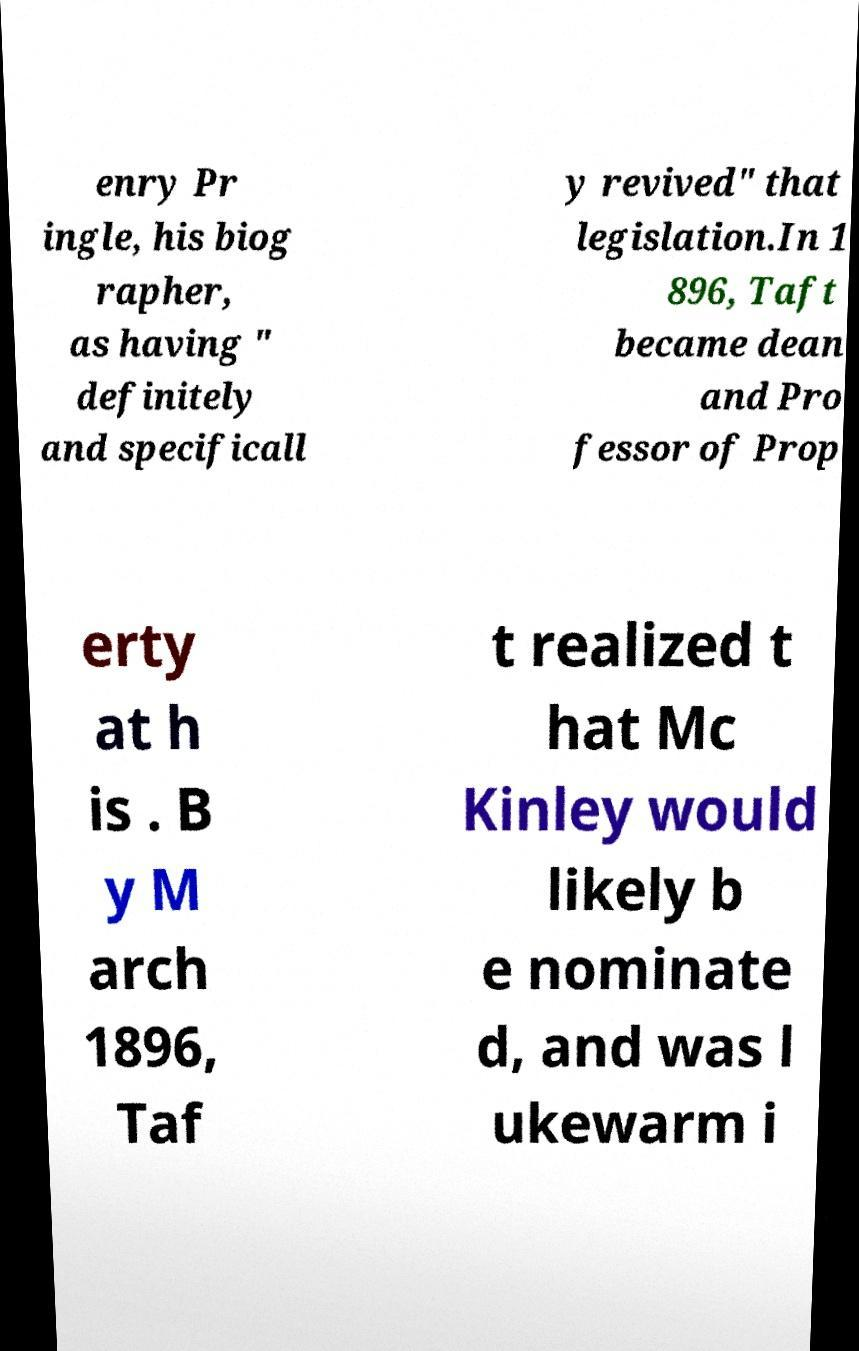Could you assist in decoding the text presented in this image and type it out clearly? enry Pr ingle, his biog rapher, as having " definitely and specificall y revived" that legislation.In 1 896, Taft became dean and Pro fessor of Prop erty at h is . B y M arch 1896, Taf t realized t hat Mc Kinley would likely b e nominate d, and was l ukewarm i 